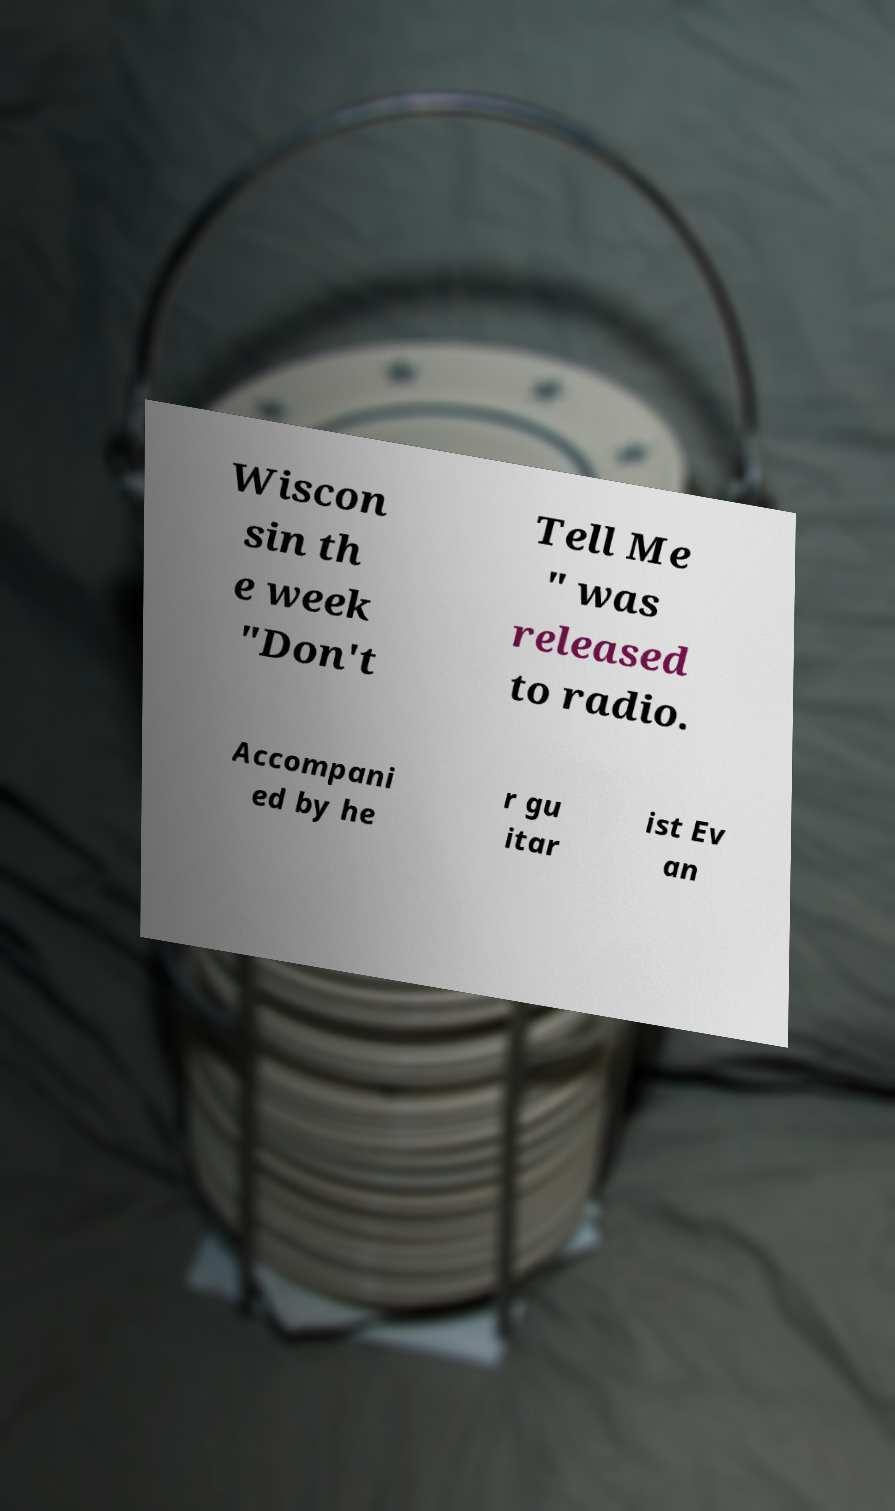I need the written content from this picture converted into text. Can you do that? Wiscon sin th e week "Don't Tell Me " was released to radio. Accompani ed by he r gu itar ist Ev an 